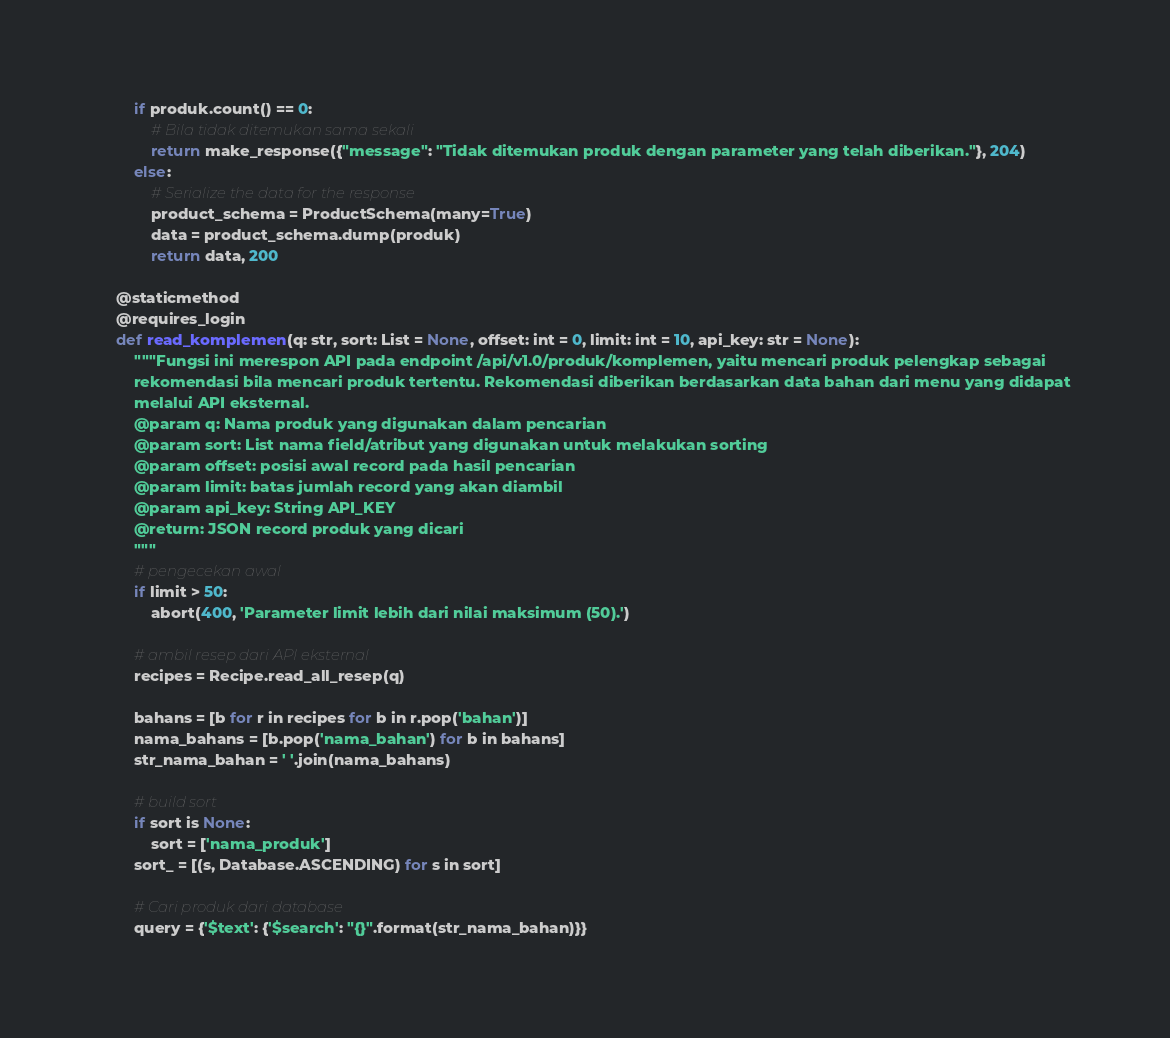Convert code to text. <code><loc_0><loc_0><loc_500><loc_500><_Python_>        if produk.count() == 0:
            # Bila tidak ditemukan sama sekali
            return make_response({"message": "Tidak ditemukan produk dengan parameter yang telah diberikan."}, 204)
        else:
            # Serialize the data for the response
            product_schema = ProductSchema(many=True)
            data = product_schema.dump(produk)
            return data, 200

    @staticmethod
    @requires_login
    def read_komplemen(q: str, sort: List = None, offset: int = 0, limit: int = 10, api_key: str = None):
        """Fungsi ini merespon API pada endpoint /api/v1.0/produk/komplemen, yaitu mencari produk pelengkap sebagai
        rekomendasi bila mencari produk tertentu. Rekomendasi diberikan berdasarkan data bahan dari menu yang didapat
        melalui API eksternal.
        @param q: Nama produk yang digunakan dalam pencarian
        @param sort: List nama field/atribut yang digunakan untuk melakukan sorting
        @param offset: posisi awal record pada hasil pencarian
        @param limit: batas jumlah record yang akan diambil
        @param api_key: String API_KEY
        @return: JSON record produk yang dicari
        """
        # pengecekan awal
        if limit > 50:
            abort(400, 'Parameter limit lebih dari nilai maksimum (50).')

        # ambil resep dari API eksternal
        recipes = Recipe.read_all_resep(q)

        bahans = [b for r in recipes for b in r.pop('bahan')]
        nama_bahans = [b.pop('nama_bahan') for b in bahans]
        str_nama_bahan = ' '.join(nama_bahans)

        # build sort
        if sort is None:
            sort = ['nama_produk']
        sort_ = [(s, Database.ASCENDING) for s in sort]

        # Cari produk dari database
        query = {'$text': {'$search': "{}".format(str_nama_bahan)}}</code> 